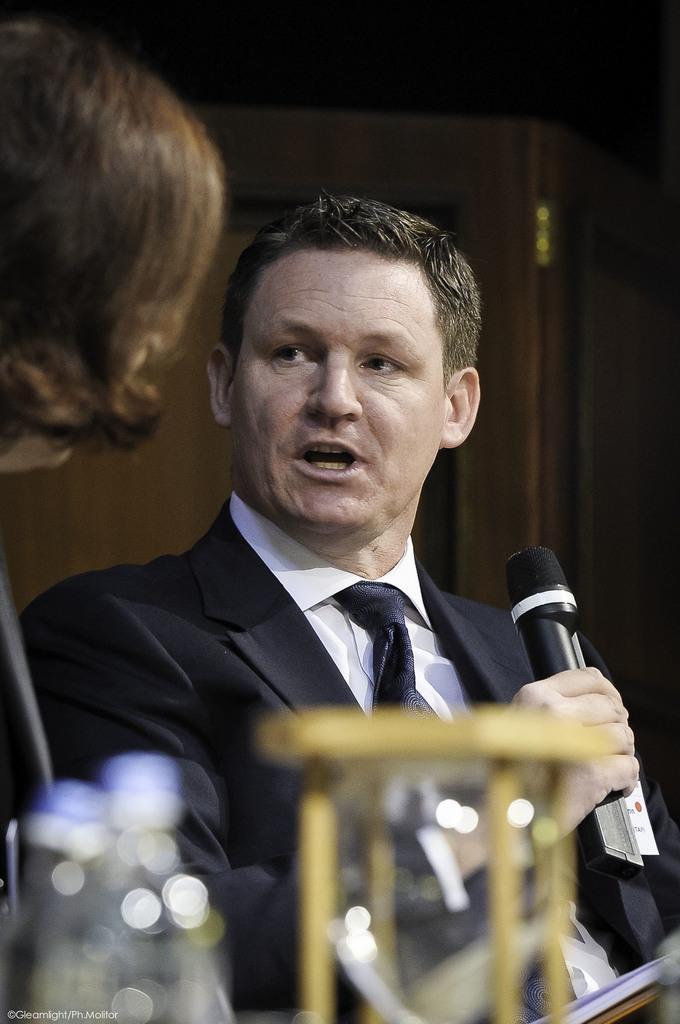Describe this image in one or two sentences. This image consists of a man and a woman. That man is wearing black color blazer and he is holding mic in his hand. 